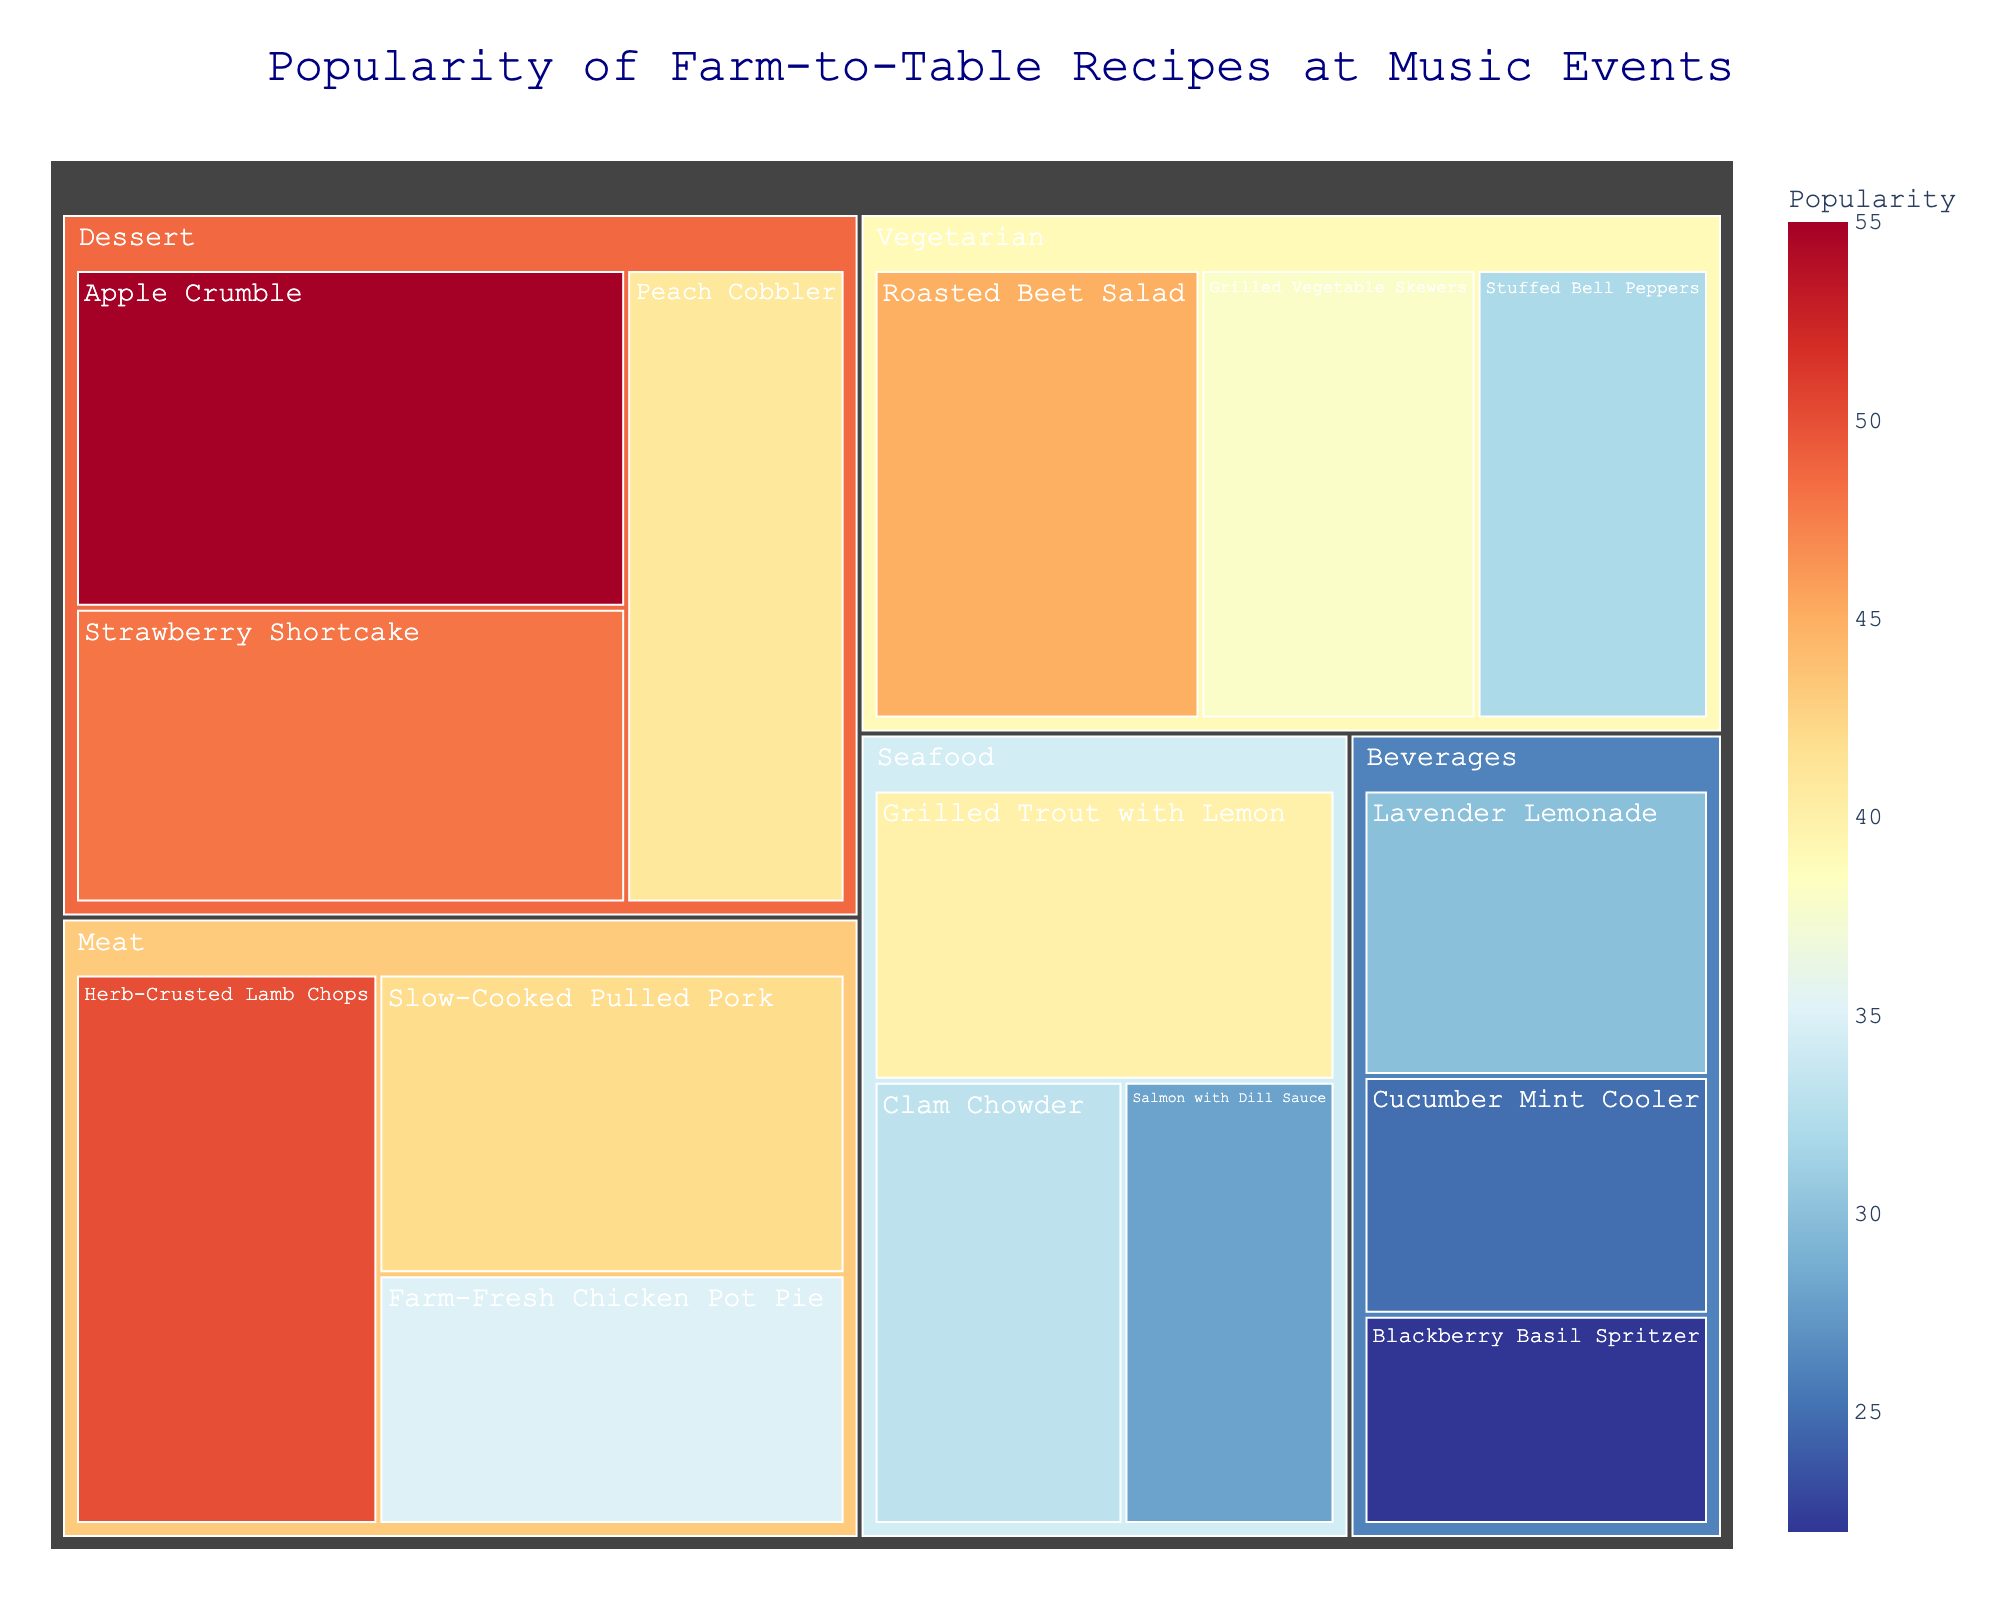Which recipe has the highest popularity? Look at the treemap's largest and most prominent colored block, which indicates the recipe with the greatest value.
Answer: Apple Crumble What is the color scheme used in the treemap to represent popularity? Observe the color variations in the figure, where color intensity portrays value differences. The colors range from blue to red.
Answer: Blue to Red Which category has the highest total popularity? Sum the values of each subcategory within categories. Dessert has values 55, 48, and 41, which sums to 144, the highest total.
Answer: Dessert Compare the popularity of Roasted Beet Salad and Farm-Fresh Chicken Pot Pie. Which is more popular and by how much? Roasted Beet Salad has a popularity of 45, while Farm-Fresh Chicken Pot Pie has 35. Calculate the difference: 45 - 35 = 10.
Answer: Roasted Beet Salad by 10 What is the average popularity of the Beverage category? Sum the values of all subcategories in Beverages (30, 25, 22) and divide by the number of subcategories: (30 + 25 + 22) / 3 = 25.67.
Answer: 25.67 Which category has the least popular subcategory? Identify the subcategory with the lowest value in the treemap. Beverages has Blackberry Basil Spritzer with a value of 22.
Answer: Beverages Compare the total popularity between Meat and Seafood categories. Which one is higher? Sum the values in Meat (50, 42, 35) and Seafood (40, 33, 28). Meat: 127, Seafood: 101; 127 is greater than 101.
Answer: Meat Which Dessert recipe is the second most popular? In the Dessert category, organize the recipes by their values. Strawberry Shortcake (48) is the second highest after Apple Crumble (55).
Answer: Strawberry Shortcake What is the popularity difference between the most popular Vegetarian recipe and the least popular Seafood recipe? Roasted Beet Salad (45) is the most popular Vegetarian recipe, and Salmon with Dill Sauce (28) is the least popular Seafood recipe. The difference is 45 - 28 = 17.
Answer: 17 In the treemap, which color likely represents the highest popularity values? Identify the most intense color in the positive end of the scale, which indicates the highest values.
Answer: Red 